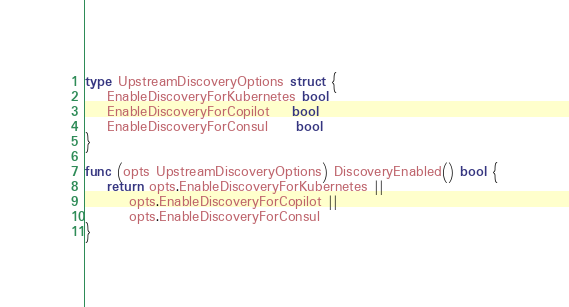<code> <loc_0><loc_0><loc_500><loc_500><_Go_>type UpstreamDiscoveryOptions struct {
	EnableDiscoveryForKubernetes bool
	EnableDiscoveryForCopilot    bool
	EnableDiscoveryForConsul     bool
}

func (opts UpstreamDiscoveryOptions) DiscoveryEnabled() bool {
	return opts.EnableDiscoveryForKubernetes ||
		opts.EnableDiscoveryForCopilot ||
		opts.EnableDiscoveryForConsul
}
</code> 